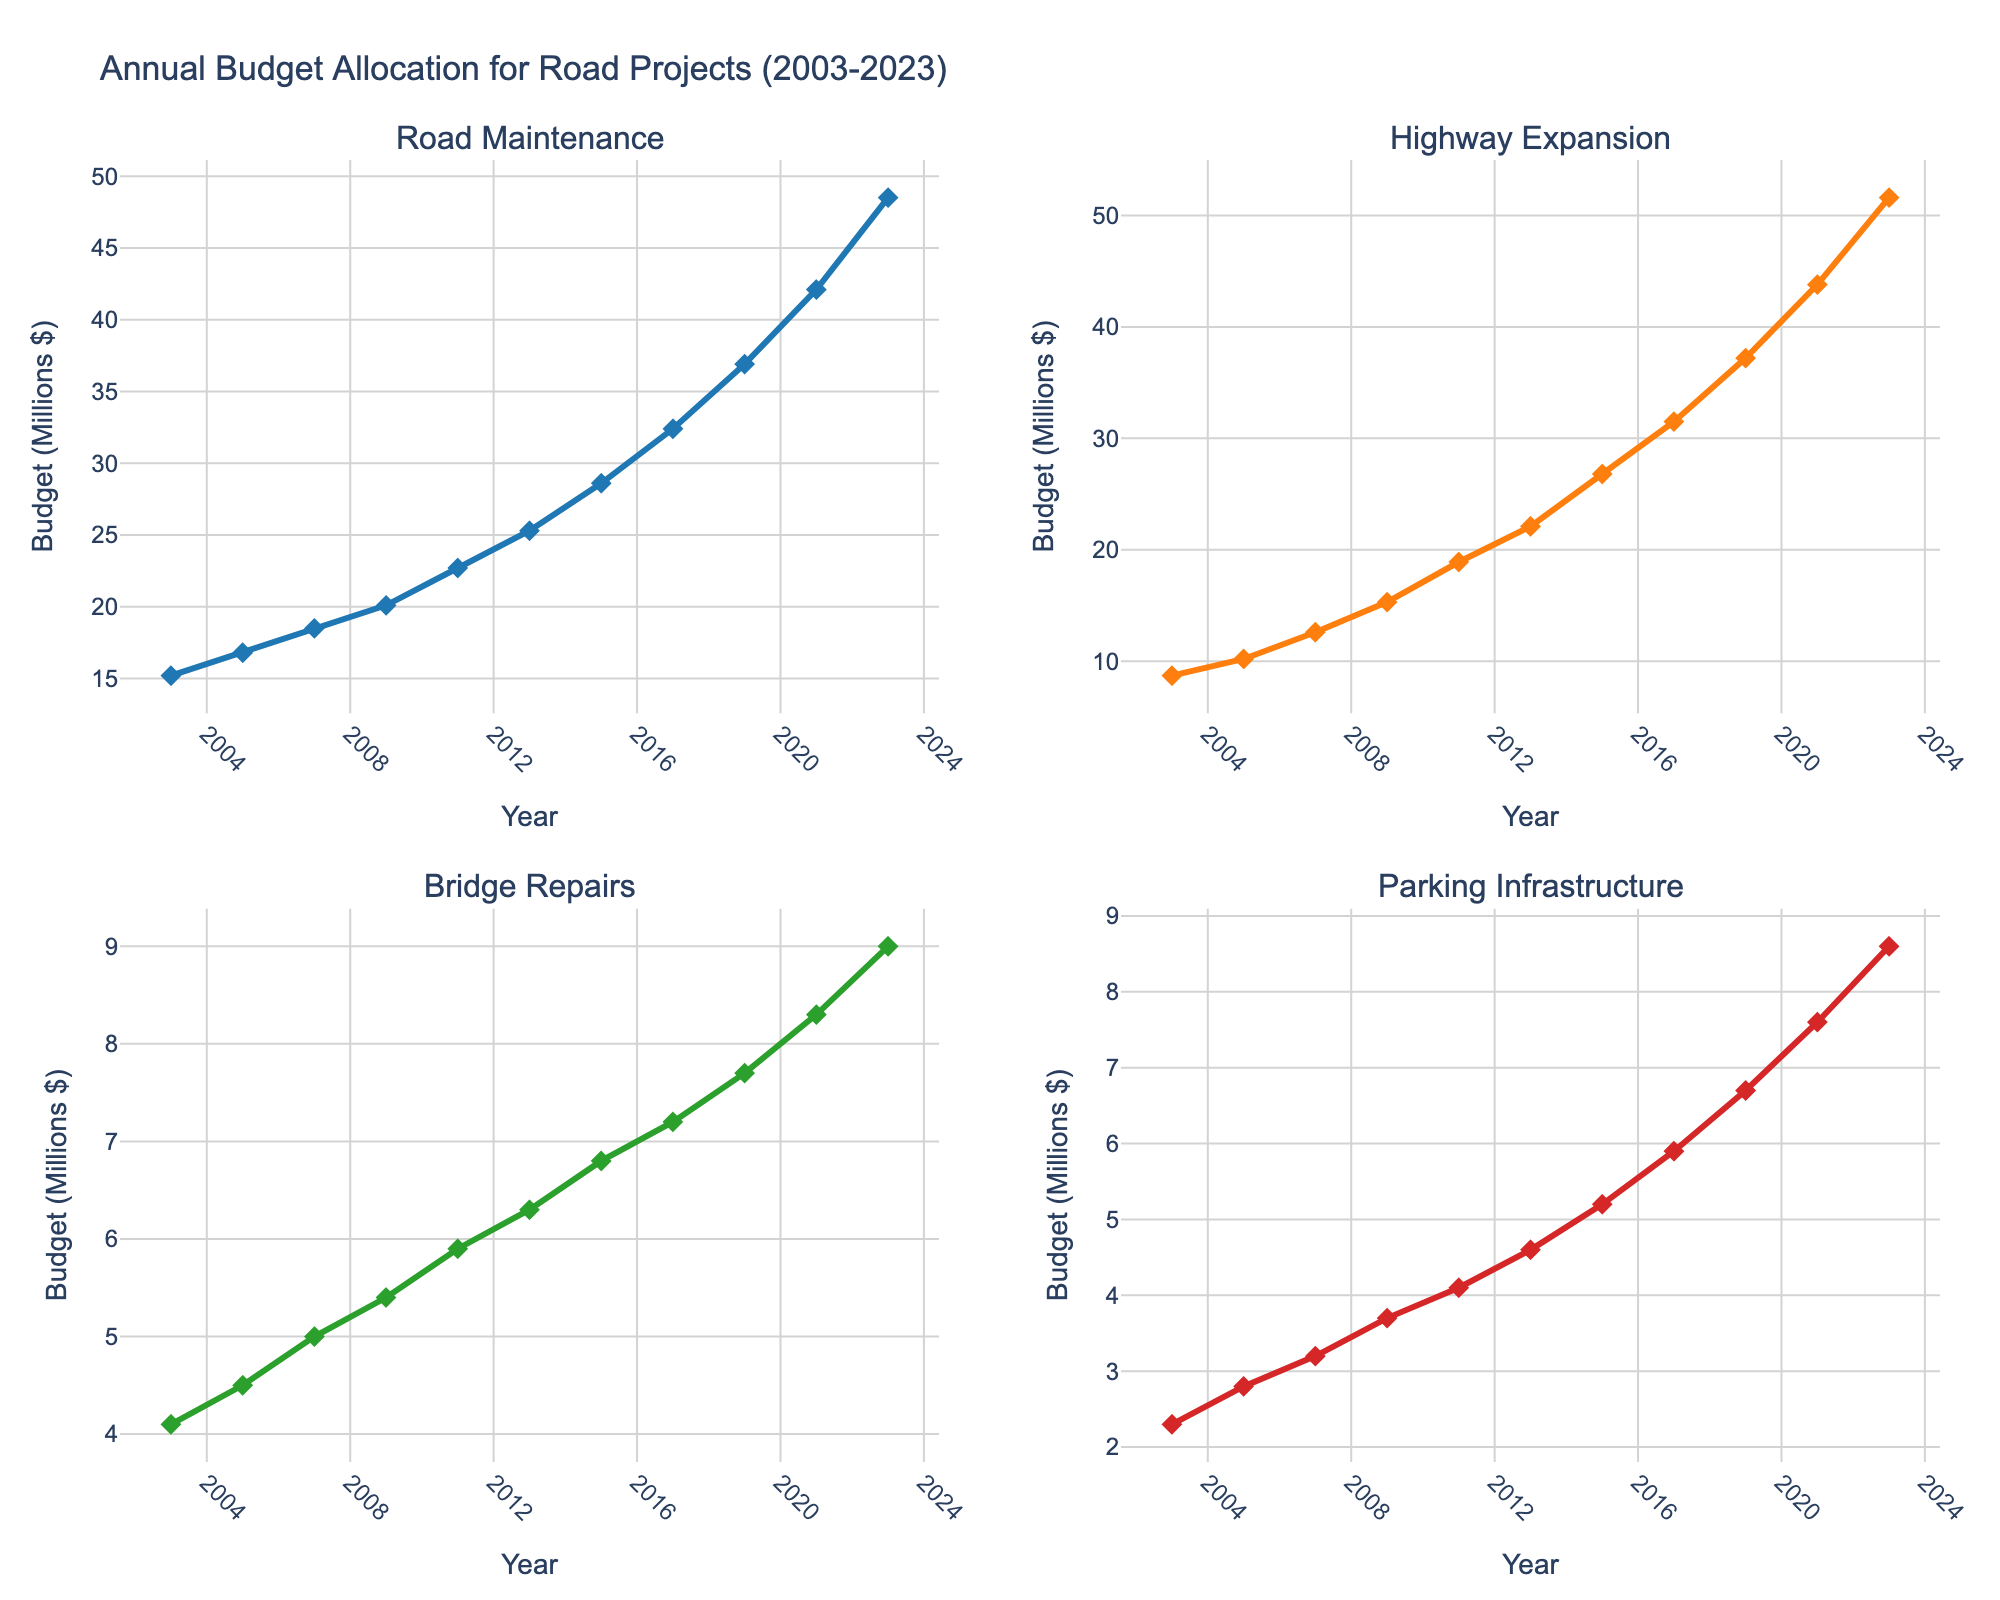What is the title of the figure? The title is displayed at the top of the plot and provides a summary of what the figure is about.
Answer: Annual Budget Allocation for Road Projects (2003-2023) How does the budget for Road Maintenance change from 2003 to 2023? According to the line chart for Road Maintenance, the value on the y-axis shows an increase from 15.2 million dollars in 2003 to 48.5 million dollars in 2023.
Answer: It increases Which year saw the highest increase in the budget for Highway Expansion, and what was that increase? To find this, compare each year with the next one for maximum change. The largest difference is between 2021 (43.8) and 2023 (51.6), an increase of 51.6 - 43.8 = 7.8 million dollars.
Answer: 2023, 7.8 million dollars How does the budget allocation for Parking Infrastructure in 2009 compare to Bridge Repairs in the same year? For 2009, Parking Infrastructure is 3.7 million dollars and Bridge Repairs is 5.4 million dollars. Comparing them directly, Parking Infrastructure is less than Bridge Repairs.
Answer: Parking Infrastructure is less What's the average annual budget allocation for Bridge Repairs over the 20-year period? Sum the Bridge Repairs values for all years and divide by the number of years (11). (4.1+4.5+5.0+5.4+5.9+6.3+6.8+7.2+7.7+8.3+9.0)/11 ≈ 6.27 million dollars.
Answer: 6.27 million dollars In which subplots do the line charts appear for Road Maintenance and Highway Expansion? Road Maintenance is in the top-left subplot, and Highway Expansion is in the top-right subplot as indicated by their respective titles within the figure.
Answer: Top-left, top-right Which category had the most consistent growth over the 20 years, and how can you tell? Road Maintenance shows the most consistent growth. Observing the line trajectory, it has a steady, upward trend without sharp increases or decreases compared to the other categories.
Answer: Road Maintenance Between 2017 and 2023, which category had the highest total budget allocation increase? Find the difference between 2023 and 2017 values for each category: Road Maintenance (48.5-32.4=16.1), Highway Expansion (51.6-31.5=20.1), Bridge Repairs (9.0-7.2=1.8), Parking Infrastructure (8.6-5.9=2.7). Highway Expansion had the highest increase of 20.1 million dollars.
Answer: Highway Expansion What was the budget allocation for Parking Infrastructure in 2011 and how does it compare to the budget in 2023? From the chart, in 2011 Parking Infrastructure was 4.1 million dollars, and in 2023 it was 8.6 million dollars. 8.6 is more than 4.1, indicating an increase.
Answer: 4.1 million dollars; it increased 